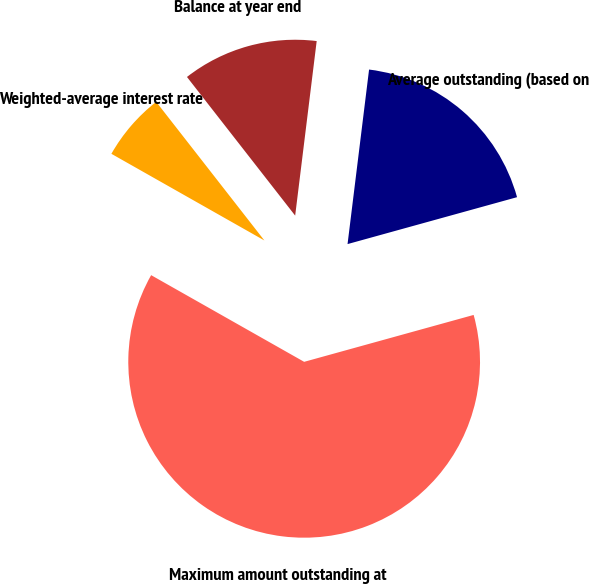Convert chart to OTSL. <chart><loc_0><loc_0><loc_500><loc_500><pie_chart><fcel>Balance at year end<fcel>Average outstanding (based on<fcel>Maximum amount outstanding at<fcel>Weighted-average interest rate<nl><fcel>12.5%<fcel>18.75%<fcel>62.5%<fcel>6.25%<nl></chart> 